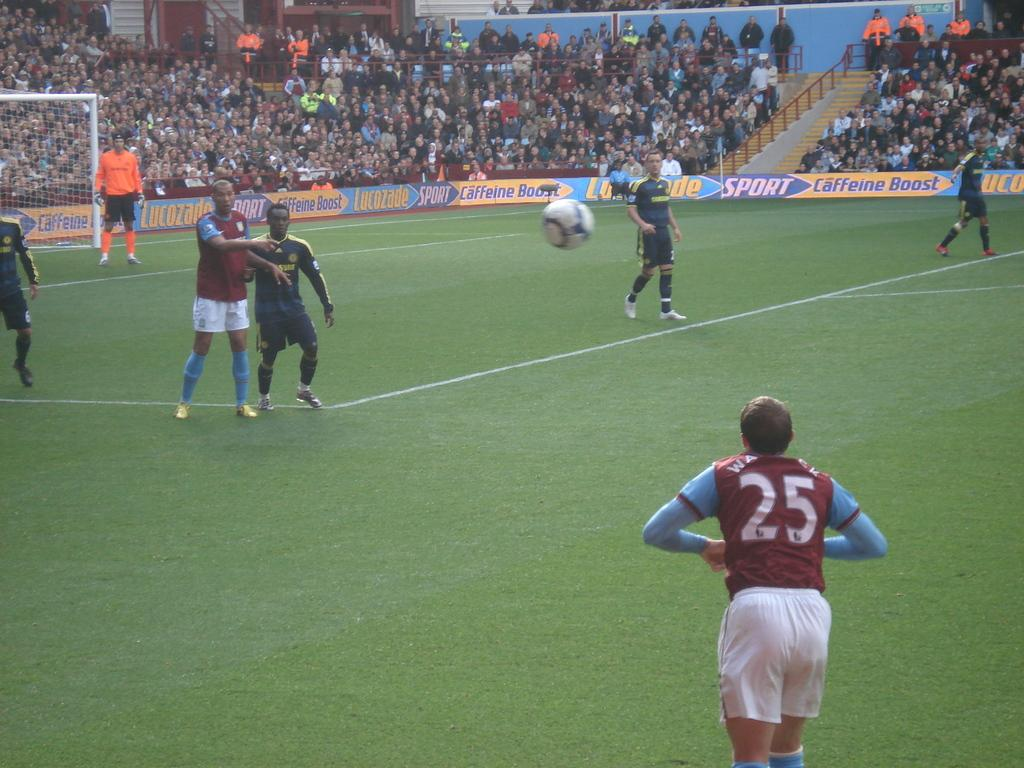<image>
Write a terse but informative summary of the picture. A soccer player wearing number 25 throws the ball in during a match. 